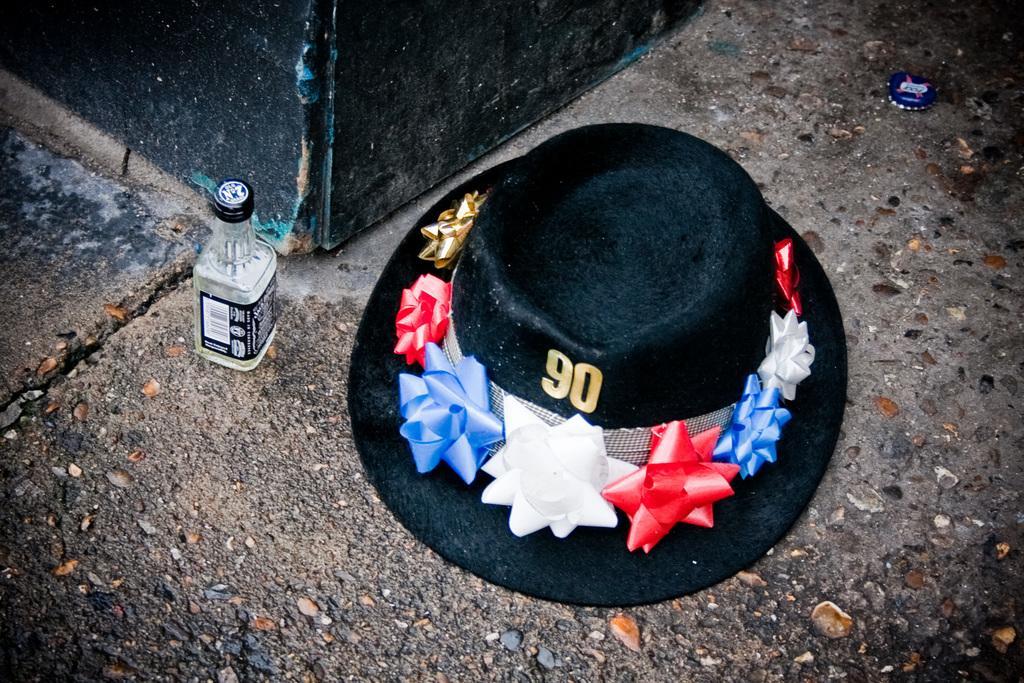Could you give a brief overview of what you see in this image? This picture seems to be of outside. In the foreground there is a black color hat placed on the ground and on the left there is a bottle placed on the ground and in the background we can see e black color metal. 